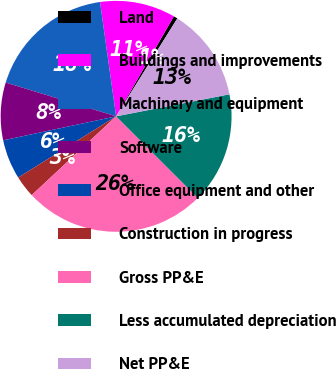Convert chart to OTSL. <chart><loc_0><loc_0><loc_500><loc_500><pie_chart><fcel>Land<fcel>Buildings and improvements<fcel>Machinery and equipment<fcel>Software<fcel>Office equipment and other<fcel>Construction in progress<fcel>Gross PP&E<fcel>Less accumulated depreciation<fcel>Net PP&E<nl><fcel>0.56%<fcel>10.56%<fcel>18.05%<fcel>8.06%<fcel>5.56%<fcel>3.06%<fcel>25.55%<fcel>15.55%<fcel>13.05%<nl></chart> 